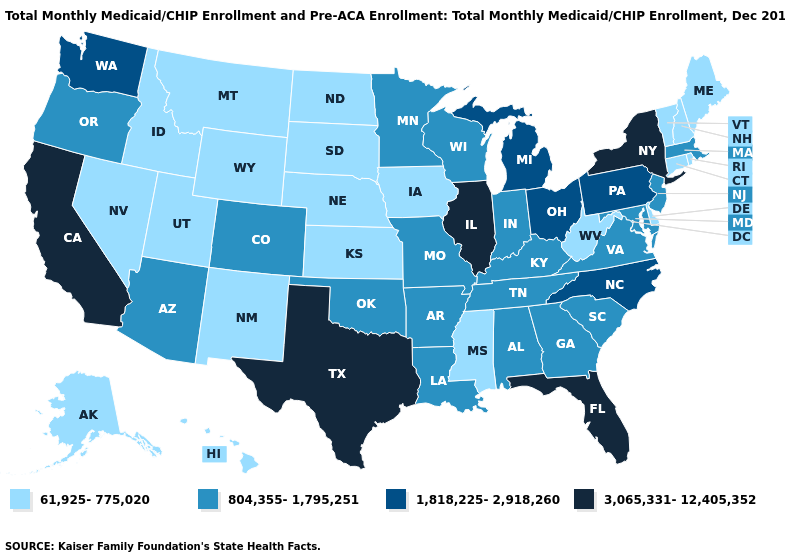Does New Jersey have the highest value in the Northeast?
Be succinct. No. Name the states that have a value in the range 3,065,331-12,405,352?
Concise answer only. California, Florida, Illinois, New York, Texas. What is the value of Montana?
Quick response, please. 61,925-775,020. Which states hav the highest value in the West?
Concise answer only. California. How many symbols are there in the legend?
Keep it brief. 4. What is the lowest value in states that border Ohio?
Concise answer only. 61,925-775,020. What is the highest value in states that border Connecticut?
Keep it brief. 3,065,331-12,405,352. Name the states that have a value in the range 61,925-775,020?
Write a very short answer. Alaska, Connecticut, Delaware, Hawaii, Idaho, Iowa, Kansas, Maine, Mississippi, Montana, Nebraska, Nevada, New Hampshire, New Mexico, North Dakota, Rhode Island, South Dakota, Utah, Vermont, West Virginia, Wyoming. Name the states that have a value in the range 804,355-1,795,251?
Write a very short answer. Alabama, Arizona, Arkansas, Colorado, Georgia, Indiana, Kentucky, Louisiana, Maryland, Massachusetts, Minnesota, Missouri, New Jersey, Oklahoma, Oregon, South Carolina, Tennessee, Virginia, Wisconsin. What is the value of Wisconsin?
Give a very brief answer. 804,355-1,795,251. What is the value of Hawaii?
Concise answer only. 61,925-775,020. What is the value of North Dakota?
Quick response, please. 61,925-775,020. Which states have the highest value in the USA?
Keep it brief. California, Florida, Illinois, New York, Texas. Name the states that have a value in the range 3,065,331-12,405,352?
Concise answer only. California, Florida, Illinois, New York, Texas. How many symbols are there in the legend?
Concise answer only. 4. 